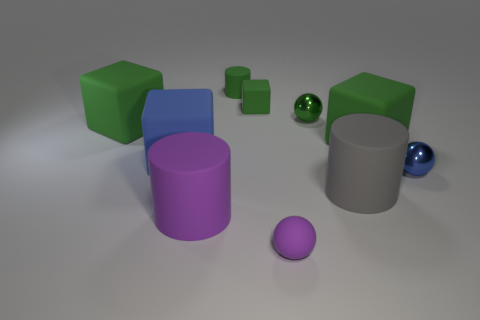Subtract all blue cylinders. How many green cubes are left? 3 Subtract all shiny balls. How many balls are left? 1 Subtract all blue cubes. How many cubes are left? 3 Subtract all brown cubes. Subtract all red cylinders. How many cubes are left? 4 Add 3 gray matte spheres. How many gray matte spheres exist? 3 Subtract 0 cyan balls. How many objects are left? 10 Subtract all cubes. How many objects are left? 6 Subtract all large blue metallic cylinders. Subtract all green matte things. How many objects are left? 6 Add 3 small green cubes. How many small green cubes are left? 4 